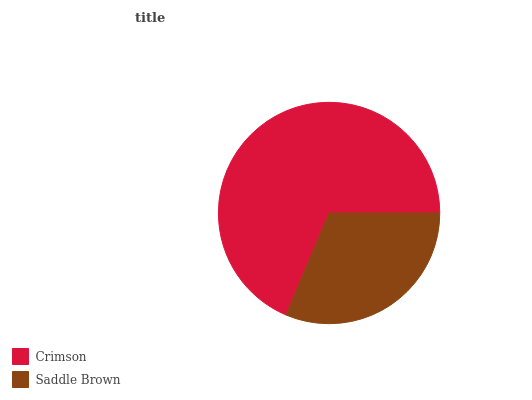Is Saddle Brown the minimum?
Answer yes or no. Yes. Is Crimson the maximum?
Answer yes or no. Yes. Is Saddle Brown the maximum?
Answer yes or no. No. Is Crimson greater than Saddle Brown?
Answer yes or no. Yes. Is Saddle Brown less than Crimson?
Answer yes or no. Yes. Is Saddle Brown greater than Crimson?
Answer yes or no. No. Is Crimson less than Saddle Brown?
Answer yes or no. No. Is Crimson the high median?
Answer yes or no. Yes. Is Saddle Brown the low median?
Answer yes or no. Yes. Is Saddle Brown the high median?
Answer yes or no. No. Is Crimson the low median?
Answer yes or no. No. 